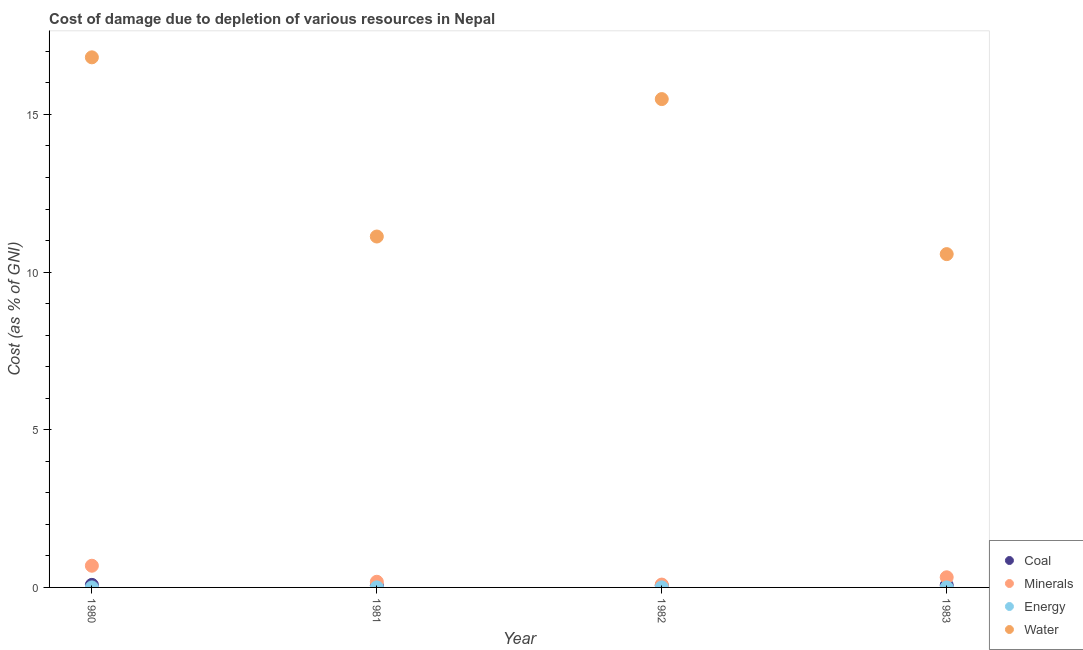What is the cost of damage due to depletion of energy in 1981?
Provide a short and direct response. 0. Across all years, what is the maximum cost of damage due to depletion of water?
Offer a very short reply. 16.81. Across all years, what is the minimum cost of damage due to depletion of coal?
Offer a terse response. 0.06. What is the total cost of damage due to depletion of water in the graph?
Your answer should be compact. 54. What is the difference between the cost of damage due to depletion of minerals in 1980 and that in 1982?
Offer a very short reply. 0.6. What is the difference between the cost of damage due to depletion of water in 1983 and the cost of damage due to depletion of minerals in 1980?
Provide a short and direct response. 9.88. What is the average cost of damage due to depletion of coal per year?
Give a very brief answer. 0.07. In the year 1980, what is the difference between the cost of damage due to depletion of water and cost of damage due to depletion of coal?
Ensure brevity in your answer.  16.73. What is the ratio of the cost of damage due to depletion of energy in 1980 to that in 1982?
Your response must be concise. 0.46. Is the cost of damage due to depletion of water in 1982 less than that in 1983?
Your response must be concise. No. What is the difference between the highest and the second highest cost of damage due to depletion of minerals?
Provide a short and direct response. 0.37. What is the difference between the highest and the lowest cost of damage due to depletion of energy?
Ensure brevity in your answer.  0. In how many years, is the cost of damage due to depletion of water greater than the average cost of damage due to depletion of water taken over all years?
Provide a succinct answer. 2. Is it the case that in every year, the sum of the cost of damage due to depletion of minerals and cost of damage due to depletion of energy is greater than the sum of cost of damage due to depletion of water and cost of damage due to depletion of coal?
Make the answer very short. Yes. Is it the case that in every year, the sum of the cost of damage due to depletion of coal and cost of damage due to depletion of minerals is greater than the cost of damage due to depletion of energy?
Make the answer very short. Yes. Does the cost of damage due to depletion of water monotonically increase over the years?
Give a very brief answer. No. How many years are there in the graph?
Your response must be concise. 4. Are the values on the major ticks of Y-axis written in scientific E-notation?
Make the answer very short. No. Does the graph contain grids?
Your answer should be very brief. No. How many legend labels are there?
Keep it short and to the point. 4. How are the legend labels stacked?
Offer a very short reply. Vertical. What is the title of the graph?
Offer a terse response. Cost of damage due to depletion of various resources in Nepal . Does "Interest Payments" appear as one of the legend labels in the graph?
Your answer should be compact. No. What is the label or title of the X-axis?
Provide a succinct answer. Year. What is the label or title of the Y-axis?
Ensure brevity in your answer.  Cost (as % of GNI). What is the Cost (as % of GNI) in Coal in 1980?
Provide a succinct answer. 0.08. What is the Cost (as % of GNI) in Minerals in 1980?
Your answer should be very brief. 0.69. What is the Cost (as % of GNI) in Energy in 1980?
Make the answer very short. 0. What is the Cost (as % of GNI) of Water in 1980?
Your answer should be compact. 16.81. What is the Cost (as % of GNI) of Coal in 1981?
Offer a very short reply. 0.06. What is the Cost (as % of GNI) in Minerals in 1981?
Provide a succinct answer. 0.18. What is the Cost (as % of GNI) in Energy in 1981?
Offer a very short reply. 0. What is the Cost (as % of GNI) of Water in 1981?
Keep it short and to the point. 11.13. What is the Cost (as % of GNI) in Coal in 1982?
Make the answer very short. 0.06. What is the Cost (as % of GNI) in Minerals in 1982?
Make the answer very short. 0.09. What is the Cost (as % of GNI) of Energy in 1982?
Ensure brevity in your answer.  0. What is the Cost (as % of GNI) in Water in 1982?
Your answer should be compact. 15.49. What is the Cost (as % of GNI) of Coal in 1983?
Keep it short and to the point. 0.07. What is the Cost (as % of GNI) in Minerals in 1983?
Keep it short and to the point. 0.32. What is the Cost (as % of GNI) of Energy in 1983?
Your response must be concise. 0. What is the Cost (as % of GNI) of Water in 1983?
Give a very brief answer. 10.57. Across all years, what is the maximum Cost (as % of GNI) in Coal?
Offer a terse response. 0.08. Across all years, what is the maximum Cost (as % of GNI) of Minerals?
Your answer should be very brief. 0.69. Across all years, what is the maximum Cost (as % of GNI) in Energy?
Your answer should be compact. 0. Across all years, what is the maximum Cost (as % of GNI) in Water?
Give a very brief answer. 16.81. Across all years, what is the minimum Cost (as % of GNI) of Coal?
Offer a terse response. 0.06. Across all years, what is the minimum Cost (as % of GNI) in Minerals?
Your answer should be very brief. 0.09. Across all years, what is the minimum Cost (as % of GNI) in Energy?
Make the answer very short. 0. Across all years, what is the minimum Cost (as % of GNI) in Water?
Your response must be concise. 10.57. What is the total Cost (as % of GNI) of Coal in the graph?
Keep it short and to the point. 0.28. What is the total Cost (as % of GNI) of Minerals in the graph?
Offer a terse response. 1.28. What is the total Cost (as % of GNI) in Energy in the graph?
Your response must be concise. 0. What is the total Cost (as % of GNI) in Water in the graph?
Ensure brevity in your answer.  54. What is the difference between the Cost (as % of GNI) in Coal in 1980 and that in 1981?
Offer a very short reply. 0.02. What is the difference between the Cost (as % of GNI) of Minerals in 1980 and that in 1981?
Provide a succinct answer. 0.51. What is the difference between the Cost (as % of GNI) in Energy in 1980 and that in 1981?
Give a very brief answer. -0. What is the difference between the Cost (as % of GNI) in Water in 1980 and that in 1981?
Your response must be concise. 5.68. What is the difference between the Cost (as % of GNI) in Coal in 1980 and that in 1982?
Provide a short and direct response. 0.02. What is the difference between the Cost (as % of GNI) of Minerals in 1980 and that in 1982?
Provide a succinct answer. 0.6. What is the difference between the Cost (as % of GNI) in Energy in 1980 and that in 1982?
Provide a short and direct response. -0. What is the difference between the Cost (as % of GNI) in Water in 1980 and that in 1982?
Provide a short and direct response. 1.32. What is the difference between the Cost (as % of GNI) of Coal in 1980 and that in 1983?
Give a very brief answer. 0.01. What is the difference between the Cost (as % of GNI) in Minerals in 1980 and that in 1983?
Provide a short and direct response. 0.37. What is the difference between the Cost (as % of GNI) in Energy in 1980 and that in 1983?
Give a very brief answer. -0. What is the difference between the Cost (as % of GNI) in Water in 1980 and that in 1983?
Make the answer very short. 6.24. What is the difference between the Cost (as % of GNI) of Coal in 1981 and that in 1982?
Give a very brief answer. 0. What is the difference between the Cost (as % of GNI) in Minerals in 1981 and that in 1982?
Offer a very short reply. 0.09. What is the difference between the Cost (as % of GNI) of Energy in 1981 and that in 1982?
Your response must be concise. -0. What is the difference between the Cost (as % of GNI) of Water in 1981 and that in 1982?
Your answer should be compact. -4.36. What is the difference between the Cost (as % of GNI) of Coal in 1981 and that in 1983?
Your answer should be compact. -0.01. What is the difference between the Cost (as % of GNI) of Minerals in 1981 and that in 1983?
Give a very brief answer. -0.14. What is the difference between the Cost (as % of GNI) of Energy in 1981 and that in 1983?
Provide a short and direct response. 0. What is the difference between the Cost (as % of GNI) in Water in 1981 and that in 1983?
Provide a short and direct response. 0.56. What is the difference between the Cost (as % of GNI) in Coal in 1982 and that in 1983?
Offer a very short reply. -0.01. What is the difference between the Cost (as % of GNI) in Minerals in 1982 and that in 1983?
Ensure brevity in your answer.  -0.23. What is the difference between the Cost (as % of GNI) in Energy in 1982 and that in 1983?
Provide a short and direct response. 0. What is the difference between the Cost (as % of GNI) in Water in 1982 and that in 1983?
Give a very brief answer. 4.92. What is the difference between the Cost (as % of GNI) in Coal in 1980 and the Cost (as % of GNI) in Minerals in 1981?
Your response must be concise. -0.1. What is the difference between the Cost (as % of GNI) of Coal in 1980 and the Cost (as % of GNI) of Energy in 1981?
Offer a very short reply. 0.08. What is the difference between the Cost (as % of GNI) of Coal in 1980 and the Cost (as % of GNI) of Water in 1981?
Your response must be concise. -11.05. What is the difference between the Cost (as % of GNI) in Minerals in 1980 and the Cost (as % of GNI) in Energy in 1981?
Your answer should be very brief. 0.69. What is the difference between the Cost (as % of GNI) of Minerals in 1980 and the Cost (as % of GNI) of Water in 1981?
Your answer should be very brief. -10.44. What is the difference between the Cost (as % of GNI) of Energy in 1980 and the Cost (as % of GNI) of Water in 1981?
Provide a succinct answer. -11.13. What is the difference between the Cost (as % of GNI) of Coal in 1980 and the Cost (as % of GNI) of Minerals in 1982?
Provide a short and direct response. -0.01. What is the difference between the Cost (as % of GNI) of Coal in 1980 and the Cost (as % of GNI) of Energy in 1982?
Your answer should be compact. 0.08. What is the difference between the Cost (as % of GNI) of Coal in 1980 and the Cost (as % of GNI) of Water in 1982?
Your response must be concise. -15.41. What is the difference between the Cost (as % of GNI) in Minerals in 1980 and the Cost (as % of GNI) in Energy in 1982?
Give a very brief answer. 0.69. What is the difference between the Cost (as % of GNI) of Minerals in 1980 and the Cost (as % of GNI) of Water in 1982?
Offer a terse response. -14.8. What is the difference between the Cost (as % of GNI) in Energy in 1980 and the Cost (as % of GNI) in Water in 1982?
Your answer should be very brief. -15.49. What is the difference between the Cost (as % of GNI) of Coal in 1980 and the Cost (as % of GNI) of Minerals in 1983?
Ensure brevity in your answer.  -0.24. What is the difference between the Cost (as % of GNI) in Coal in 1980 and the Cost (as % of GNI) in Energy in 1983?
Provide a succinct answer. 0.08. What is the difference between the Cost (as % of GNI) in Coal in 1980 and the Cost (as % of GNI) in Water in 1983?
Offer a terse response. -10.49. What is the difference between the Cost (as % of GNI) of Minerals in 1980 and the Cost (as % of GNI) of Energy in 1983?
Offer a terse response. 0.69. What is the difference between the Cost (as % of GNI) in Minerals in 1980 and the Cost (as % of GNI) in Water in 1983?
Offer a terse response. -9.88. What is the difference between the Cost (as % of GNI) in Energy in 1980 and the Cost (as % of GNI) in Water in 1983?
Give a very brief answer. -10.57. What is the difference between the Cost (as % of GNI) of Coal in 1981 and the Cost (as % of GNI) of Minerals in 1982?
Offer a terse response. -0.03. What is the difference between the Cost (as % of GNI) of Coal in 1981 and the Cost (as % of GNI) of Energy in 1982?
Make the answer very short. 0.06. What is the difference between the Cost (as % of GNI) of Coal in 1981 and the Cost (as % of GNI) of Water in 1982?
Your response must be concise. -15.42. What is the difference between the Cost (as % of GNI) of Minerals in 1981 and the Cost (as % of GNI) of Energy in 1982?
Your response must be concise. 0.18. What is the difference between the Cost (as % of GNI) of Minerals in 1981 and the Cost (as % of GNI) of Water in 1982?
Give a very brief answer. -15.31. What is the difference between the Cost (as % of GNI) of Energy in 1981 and the Cost (as % of GNI) of Water in 1982?
Give a very brief answer. -15.49. What is the difference between the Cost (as % of GNI) in Coal in 1981 and the Cost (as % of GNI) in Minerals in 1983?
Ensure brevity in your answer.  -0.26. What is the difference between the Cost (as % of GNI) in Coal in 1981 and the Cost (as % of GNI) in Energy in 1983?
Make the answer very short. 0.06. What is the difference between the Cost (as % of GNI) in Coal in 1981 and the Cost (as % of GNI) in Water in 1983?
Your answer should be very brief. -10.51. What is the difference between the Cost (as % of GNI) in Minerals in 1981 and the Cost (as % of GNI) in Energy in 1983?
Your answer should be compact. 0.18. What is the difference between the Cost (as % of GNI) of Minerals in 1981 and the Cost (as % of GNI) of Water in 1983?
Give a very brief answer. -10.39. What is the difference between the Cost (as % of GNI) of Energy in 1981 and the Cost (as % of GNI) of Water in 1983?
Provide a short and direct response. -10.57. What is the difference between the Cost (as % of GNI) in Coal in 1982 and the Cost (as % of GNI) in Minerals in 1983?
Provide a short and direct response. -0.26. What is the difference between the Cost (as % of GNI) in Coal in 1982 and the Cost (as % of GNI) in Energy in 1983?
Your response must be concise. 0.06. What is the difference between the Cost (as % of GNI) of Coal in 1982 and the Cost (as % of GNI) of Water in 1983?
Keep it short and to the point. -10.51. What is the difference between the Cost (as % of GNI) of Minerals in 1982 and the Cost (as % of GNI) of Energy in 1983?
Make the answer very short. 0.09. What is the difference between the Cost (as % of GNI) of Minerals in 1982 and the Cost (as % of GNI) of Water in 1983?
Offer a very short reply. -10.48. What is the difference between the Cost (as % of GNI) in Energy in 1982 and the Cost (as % of GNI) in Water in 1983?
Ensure brevity in your answer.  -10.57. What is the average Cost (as % of GNI) of Coal per year?
Make the answer very short. 0.07. What is the average Cost (as % of GNI) in Minerals per year?
Ensure brevity in your answer.  0.32. What is the average Cost (as % of GNI) in Water per year?
Your response must be concise. 13.5. In the year 1980, what is the difference between the Cost (as % of GNI) of Coal and Cost (as % of GNI) of Minerals?
Give a very brief answer. -0.61. In the year 1980, what is the difference between the Cost (as % of GNI) of Coal and Cost (as % of GNI) of Energy?
Give a very brief answer. 0.08. In the year 1980, what is the difference between the Cost (as % of GNI) of Coal and Cost (as % of GNI) of Water?
Your answer should be very brief. -16.73. In the year 1980, what is the difference between the Cost (as % of GNI) in Minerals and Cost (as % of GNI) in Energy?
Offer a very short reply. 0.69. In the year 1980, what is the difference between the Cost (as % of GNI) of Minerals and Cost (as % of GNI) of Water?
Your answer should be compact. -16.12. In the year 1980, what is the difference between the Cost (as % of GNI) of Energy and Cost (as % of GNI) of Water?
Provide a succinct answer. -16.81. In the year 1981, what is the difference between the Cost (as % of GNI) in Coal and Cost (as % of GNI) in Minerals?
Offer a terse response. -0.12. In the year 1981, what is the difference between the Cost (as % of GNI) in Coal and Cost (as % of GNI) in Energy?
Offer a terse response. 0.06. In the year 1981, what is the difference between the Cost (as % of GNI) in Coal and Cost (as % of GNI) in Water?
Make the answer very short. -11.06. In the year 1981, what is the difference between the Cost (as % of GNI) in Minerals and Cost (as % of GNI) in Energy?
Provide a succinct answer. 0.18. In the year 1981, what is the difference between the Cost (as % of GNI) of Minerals and Cost (as % of GNI) of Water?
Keep it short and to the point. -10.95. In the year 1981, what is the difference between the Cost (as % of GNI) in Energy and Cost (as % of GNI) in Water?
Provide a succinct answer. -11.13. In the year 1982, what is the difference between the Cost (as % of GNI) in Coal and Cost (as % of GNI) in Minerals?
Your response must be concise. -0.03. In the year 1982, what is the difference between the Cost (as % of GNI) of Coal and Cost (as % of GNI) of Energy?
Your answer should be very brief. 0.06. In the year 1982, what is the difference between the Cost (as % of GNI) in Coal and Cost (as % of GNI) in Water?
Offer a very short reply. -15.42. In the year 1982, what is the difference between the Cost (as % of GNI) in Minerals and Cost (as % of GNI) in Energy?
Provide a succinct answer. 0.09. In the year 1982, what is the difference between the Cost (as % of GNI) in Minerals and Cost (as % of GNI) in Water?
Provide a short and direct response. -15.4. In the year 1982, what is the difference between the Cost (as % of GNI) of Energy and Cost (as % of GNI) of Water?
Offer a terse response. -15.49. In the year 1983, what is the difference between the Cost (as % of GNI) of Coal and Cost (as % of GNI) of Minerals?
Provide a succinct answer. -0.25. In the year 1983, what is the difference between the Cost (as % of GNI) in Coal and Cost (as % of GNI) in Energy?
Your answer should be very brief. 0.07. In the year 1983, what is the difference between the Cost (as % of GNI) of Coal and Cost (as % of GNI) of Water?
Keep it short and to the point. -10.5. In the year 1983, what is the difference between the Cost (as % of GNI) of Minerals and Cost (as % of GNI) of Energy?
Provide a short and direct response. 0.32. In the year 1983, what is the difference between the Cost (as % of GNI) of Minerals and Cost (as % of GNI) of Water?
Provide a succinct answer. -10.25. In the year 1983, what is the difference between the Cost (as % of GNI) of Energy and Cost (as % of GNI) of Water?
Your response must be concise. -10.57. What is the ratio of the Cost (as % of GNI) in Coal in 1980 to that in 1981?
Offer a terse response. 1.26. What is the ratio of the Cost (as % of GNI) in Minerals in 1980 to that in 1981?
Provide a short and direct response. 3.83. What is the ratio of the Cost (as % of GNI) in Energy in 1980 to that in 1981?
Your response must be concise. 0.51. What is the ratio of the Cost (as % of GNI) of Water in 1980 to that in 1981?
Your answer should be very brief. 1.51. What is the ratio of the Cost (as % of GNI) of Coal in 1980 to that in 1982?
Your answer should be compact. 1.27. What is the ratio of the Cost (as % of GNI) of Minerals in 1980 to that in 1982?
Your answer should be compact. 7.59. What is the ratio of the Cost (as % of GNI) of Energy in 1980 to that in 1982?
Make the answer very short. 0.46. What is the ratio of the Cost (as % of GNI) in Water in 1980 to that in 1982?
Keep it short and to the point. 1.09. What is the ratio of the Cost (as % of GNI) in Coal in 1980 to that in 1983?
Provide a short and direct response. 1.1. What is the ratio of the Cost (as % of GNI) in Minerals in 1980 to that in 1983?
Keep it short and to the point. 2.14. What is the ratio of the Cost (as % of GNI) in Energy in 1980 to that in 1983?
Your answer should be compact. 0.85. What is the ratio of the Cost (as % of GNI) in Water in 1980 to that in 1983?
Provide a succinct answer. 1.59. What is the ratio of the Cost (as % of GNI) in Coal in 1981 to that in 1982?
Your answer should be compact. 1. What is the ratio of the Cost (as % of GNI) in Minerals in 1981 to that in 1982?
Keep it short and to the point. 1.98. What is the ratio of the Cost (as % of GNI) of Energy in 1981 to that in 1982?
Offer a very short reply. 0.89. What is the ratio of the Cost (as % of GNI) in Water in 1981 to that in 1982?
Make the answer very short. 0.72. What is the ratio of the Cost (as % of GNI) of Coal in 1981 to that in 1983?
Provide a succinct answer. 0.87. What is the ratio of the Cost (as % of GNI) in Minerals in 1981 to that in 1983?
Your answer should be very brief. 0.56. What is the ratio of the Cost (as % of GNI) in Energy in 1981 to that in 1983?
Offer a very short reply. 1.66. What is the ratio of the Cost (as % of GNI) of Water in 1981 to that in 1983?
Offer a very short reply. 1.05. What is the ratio of the Cost (as % of GNI) in Coal in 1982 to that in 1983?
Ensure brevity in your answer.  0.87. What is the ratio of the Cost (as % of GNI) of Minerals in 1982 to that in 1983?
Keep it short and to the point. 0.28. What is the ratio of the Cost (as % of GNI) of Energy in 1982 to that in 1983?
Offer a terse response. 1.86. What is the ratio of the Cost (as % of GNI) of Water in 1982 to that in 1983?
Make the answer very short. 1.47. What is the difference between the highest and the second highest Cost (as % of GNI) in Coal?
Give a very brief answer. 0.01. What is the difference between the highest and the second highest Cost (as % of GNI) in Minerals?
Offer a very short reply. 0.37. What is the difference between the highest and the second highest Cost (as % of GNI) in Energy?
Provide a short and direct response. 0. What is the difference between the highest and the second highest Cost (as % of GNI) in Water?
Offer a terse response. 1.32. What is the difference between the highest and the lowest Cost (as % of GNI) in Coal?
Keep it short and to the point. 0.02. What is the difference between the highest and the lowest Cost (as % of GNI) in Minerals?
Offer a very short reply. 0.6. What is the difference between the highest and the lowest Cost (as % of GNI) in Energy?
Give a very brief answer. 0. What is the difference between the highest and the lowest Cost (as % of GNI) in Water?
Offer a terse response. 6.24. 